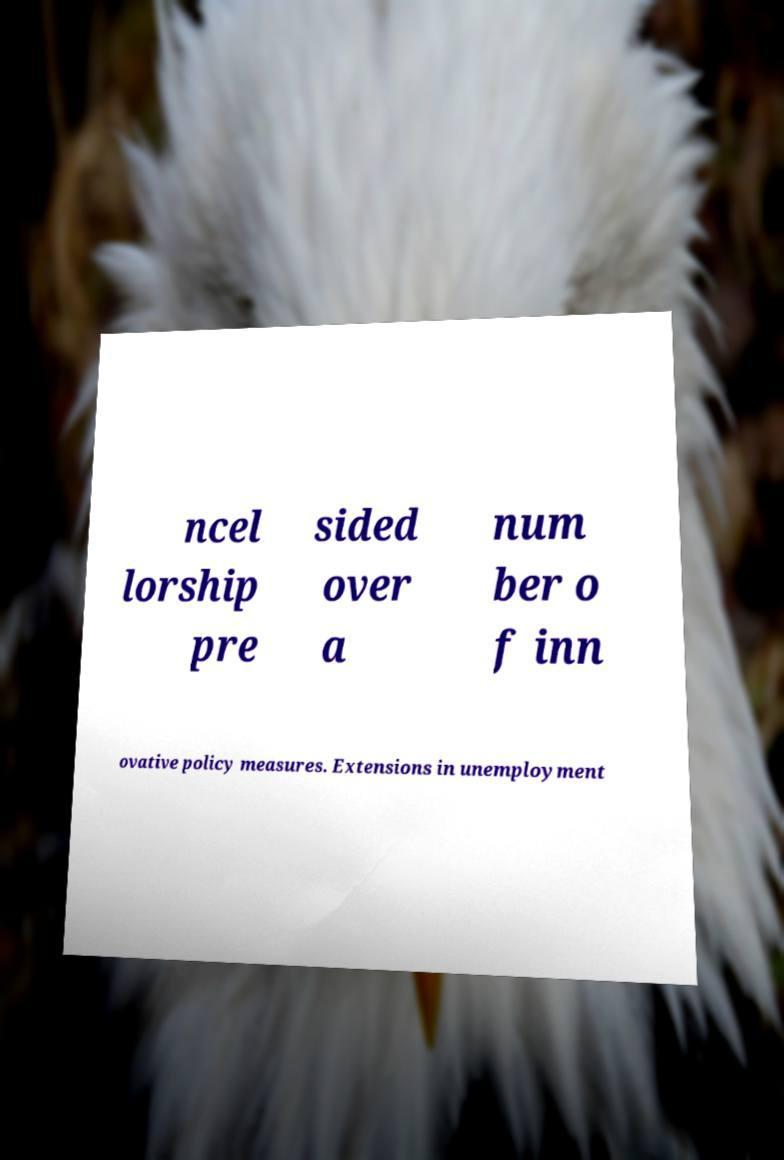Please read and relay the text visible in this image. What does it say? ncel lorship pre sided over a num ber o f inn ovative policy measures. Extensions in unemployment 